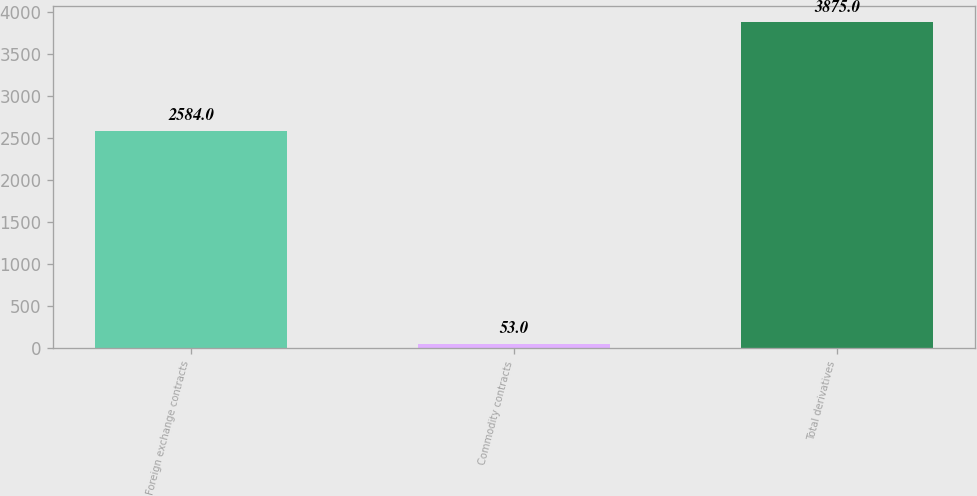Convert chart. <chart><loc_0><loc_0><loc_500><loc_500><bar_chart><fcel>Foreign exchange contracts<fcel>Commodity contracts<fcel>Total derivatives<nl><fcel>2584<fcel>53<fcel>3875<nl></chart> 